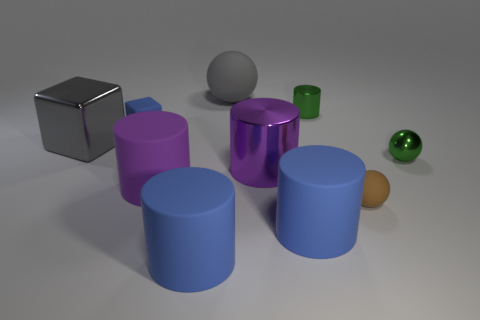Subtract all green cylinders. How many cylinders are left? 4 Subtract all tiny cylinders. How many cylinders are left? 4 Subtract all red cylinders. Subtract all brown balls. How many cylinders are left? 5 Subtract all balls. How many objects are left? 7 Add 4 big purple matte objects. How many big purple matte objects exist? 5 Subtract 1 blue cubes. How many objects are left? 9 Subtract all matte things. Subtract all big gray rubber balls. How many objects are left? 3 Add 8 small blue rubber things. How many small blue rubber things are left? 9 